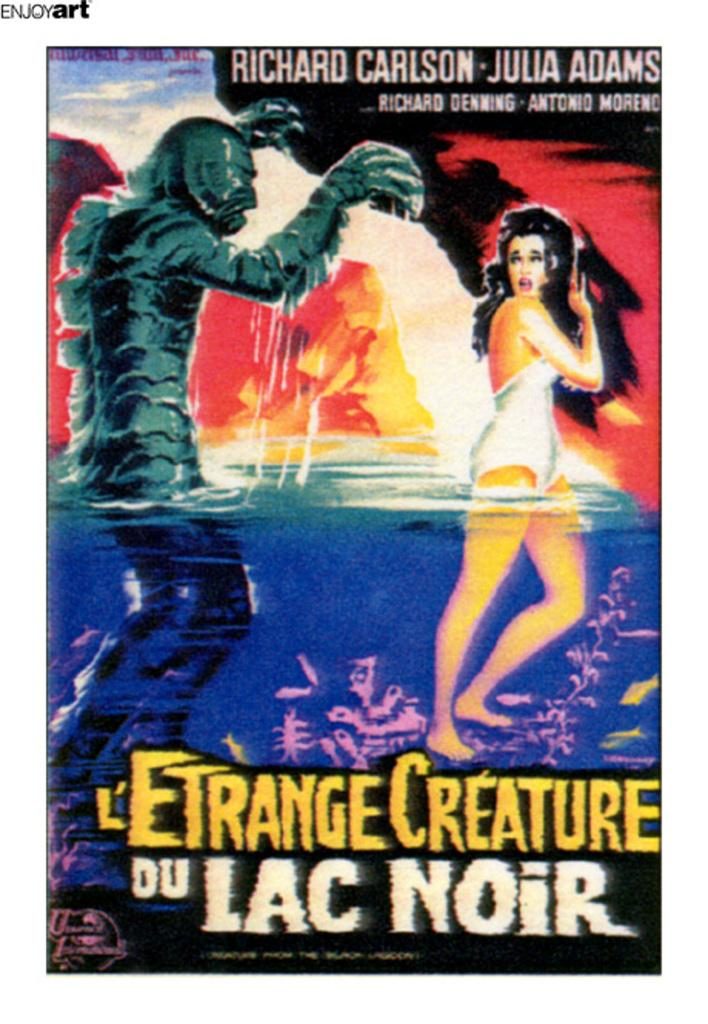<image>
Write a terse but informative summary of the picture. A movie poster for the movie L'Etrange Creature Du Lac Noir. 